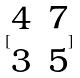<formula> <loc_0><loc_0><loc_500><loc_500>[ \begin{matrix} 4 & 7 \\ 3 & 5 \end{matrix} ]</formula> 